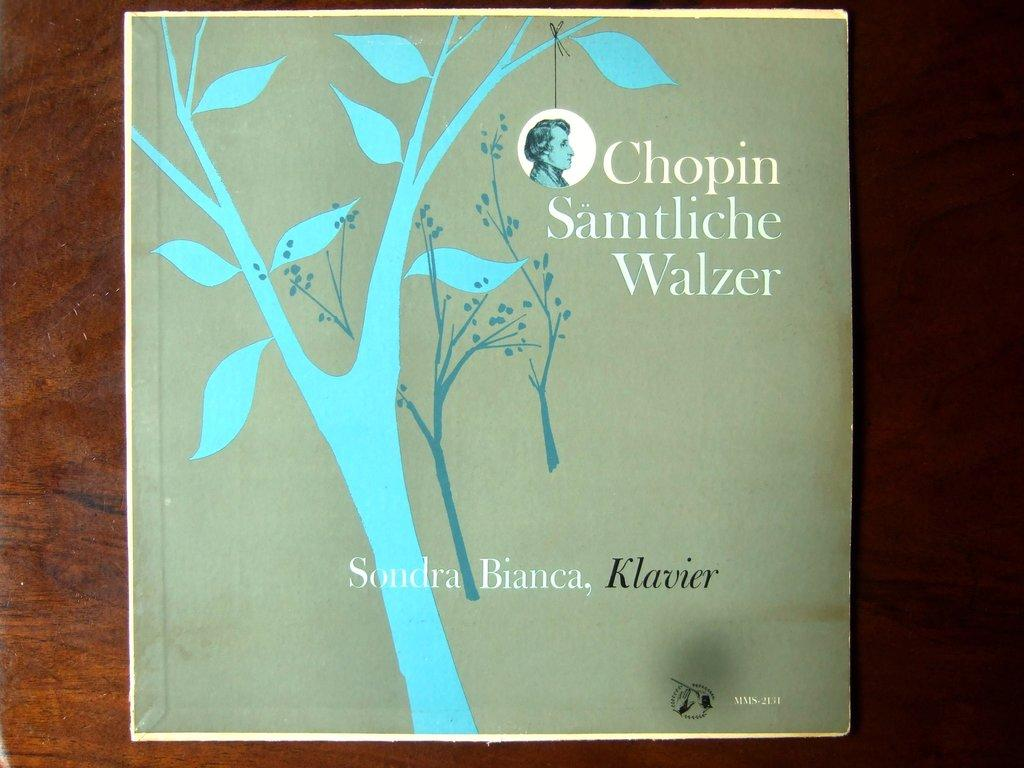<image>
Provide a brief description of the given image. A record called Chopin Samtliche Walzer is on a wooden table. 